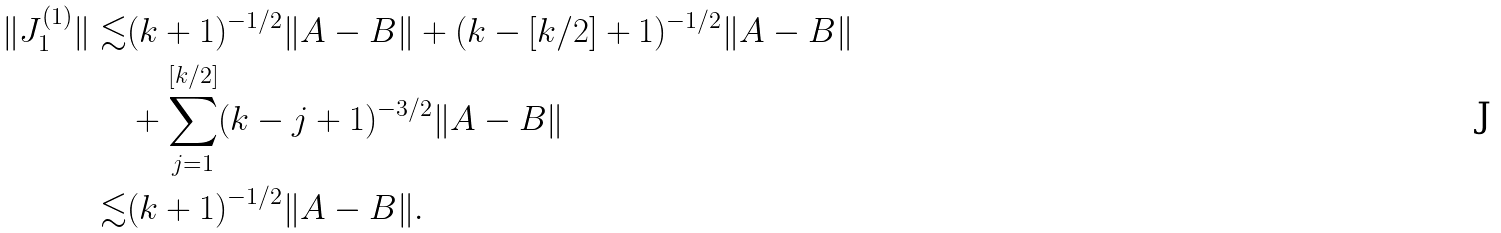<formula> <loc_0><loc_0><loc_500><loc_500>\| J _ { 1 } ^ { ( 1 ) } \| \lesssim & ( k + 1 ) ^ { - 1 / 2 } \| A - B \| + ( k - [ k / 2 ] + 1 ) ^ { - 1 / 2 } \| A - B \| \\ & + \sum _ { j = 1 } ^ { [ k / 2 ] } ( k - j + 1 ) ^ { - 3 / 2 } \| A - B \| \\ \lesssim & ( k + 1 ) ^ { - 1 / 2 } \| A - B \| .</formula> 